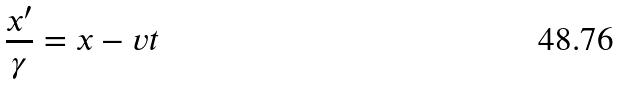Convert formula to latex. <formula><loc_0><loc_0><loc_500><loc_500>\frac { x ^ { \prime } } { \gamma } = x - v t</formula> 